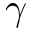Convert formula to latex. <formula><loc_0><loc_0><loc_500><loc_500>\gamma</formula> 